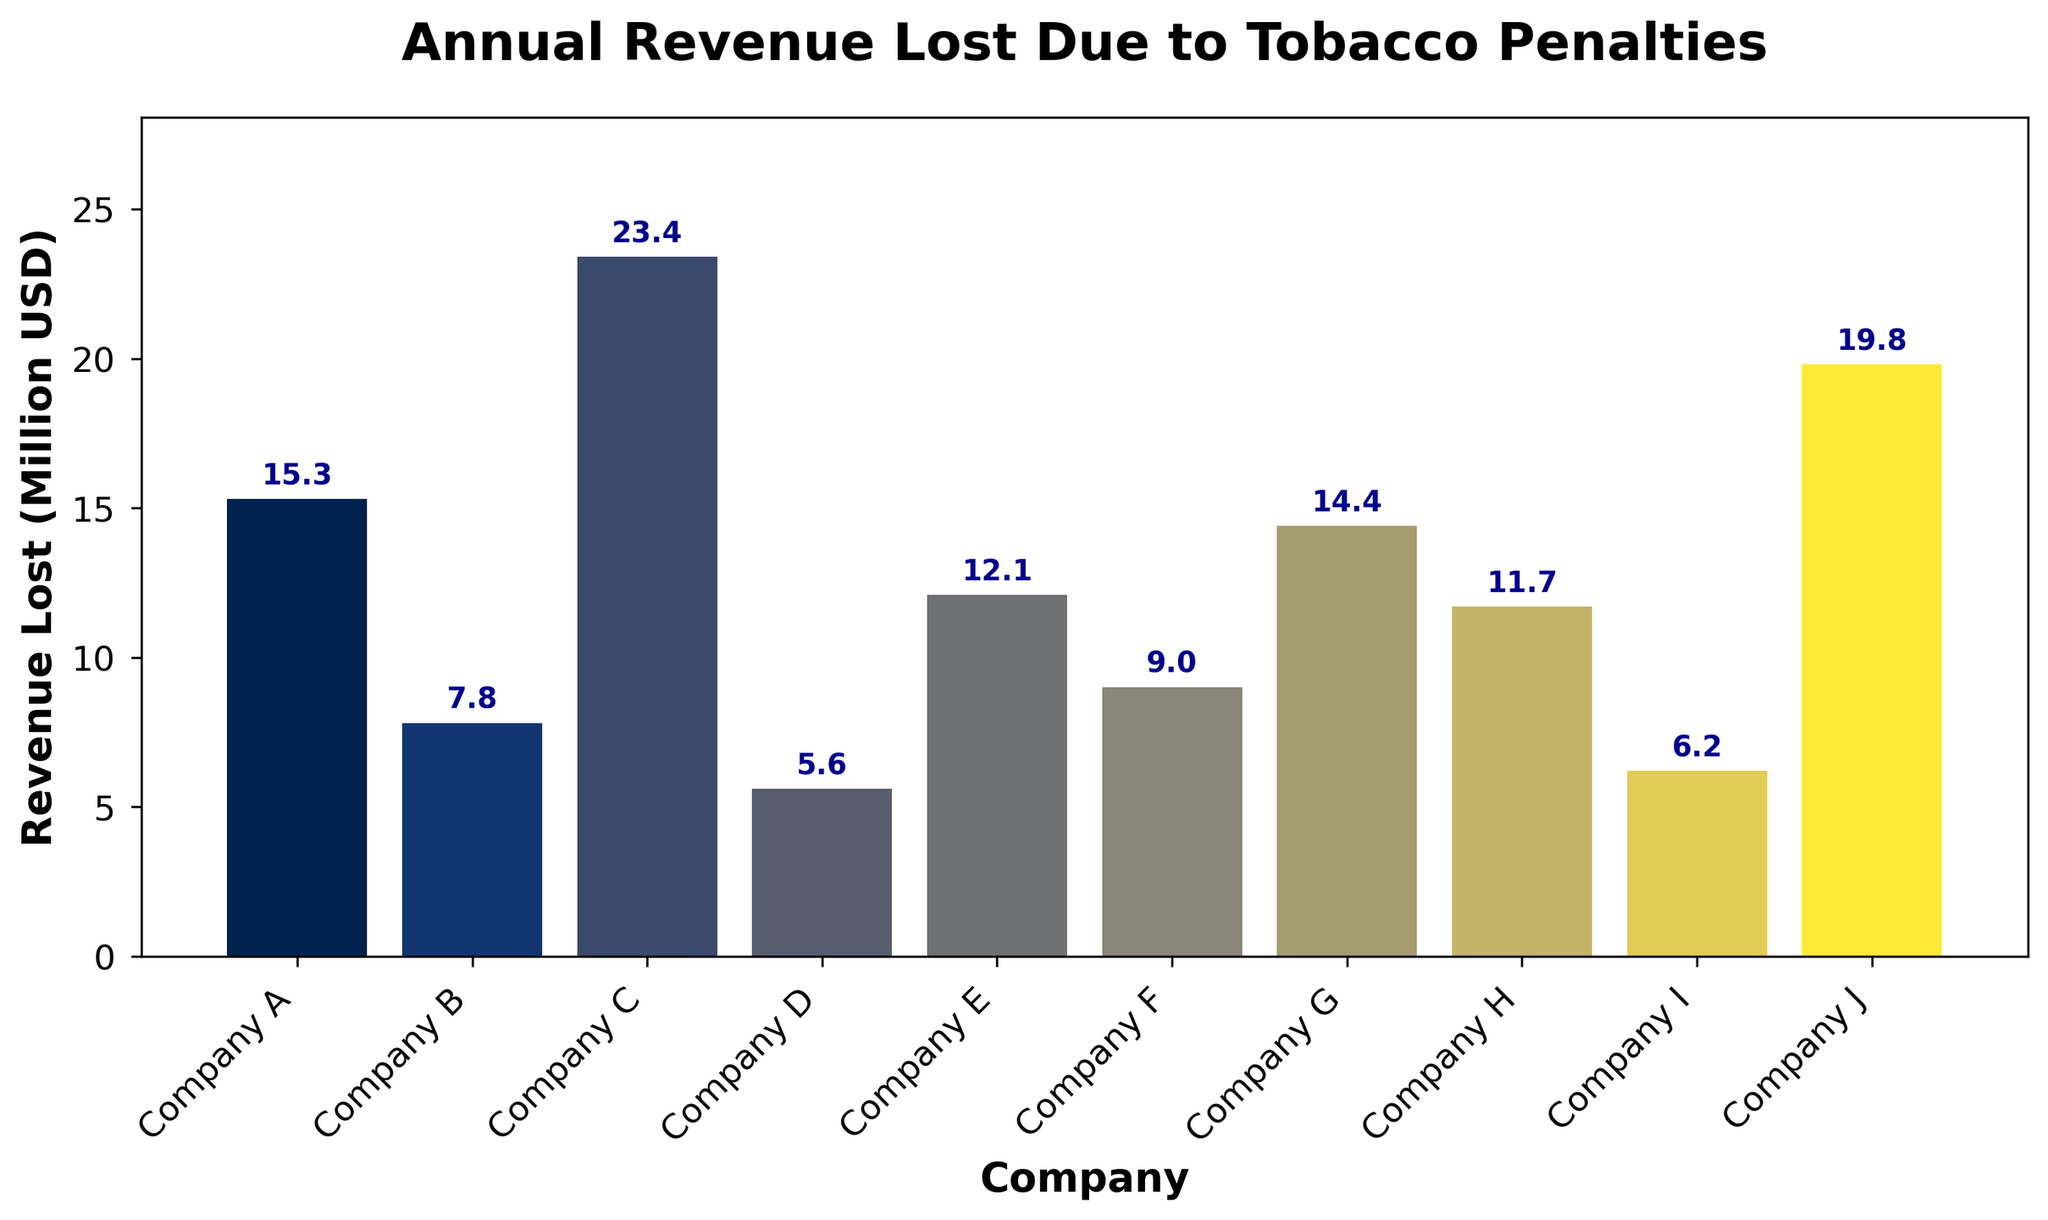Which company lost the most revenue due to tobacco penalties? The company with the highest bar in height lost the most revenue. In this case, Company C has the tallest bar.
Answer: Company C Which company lost the least revenue due to tobacco penalties? The company with the shortest bar lost the least revenue. In this case, Company D has the shortest bar.
Answer: Company D How much more revenue did Company C lose compared to Company D? Subtract the revenue lost by Company D (5.6 million USD) from the revenue lost by Company C (23.4 million USD): 23.4 - 5.6 = 17.8 million USD.
Answer: 17.8 million USD What is the total revenue lost by all companies combined? Sum the individual revenue losses: 15.3 + 7.8 + 23.4 + 5.6 + 12.1 + 9.0 + 14.4 + 11.7 + 6.2 + 19.8 = 125.3 million USD.
Answer: 125.3 million USD What is the average revenue lost due to tobacco penalties across all companies? Divide the total revenue lost by the number of companies: 125.3 million USD / 10 companies = 12.53 million USD.
Answer: 12.53 million USD Which two companies have the closest amounts of revenue lost, and what is the difference between them? Companies F and H have lost 9.0 and 11.7 million USD, respectively. The difference is
Answer: Company H and Company F How many companies lost more than 10 million USD in revenue due to tobacco penalties? Count the number of bars taller than the line representing 10 million USD: Companies A, B, C, E, G, H, and J.
Answer: 7 companies Which company has a bar that is approximately halfway between the maximum and minimum bar heights? Calculate the range of revenue lost: 23.4 (max) - 5.6 (min) = 17.8 million USD. Halfway would be 5.6 + 8.9 = 14.5 million USD. Closest bars are Company A (15.3) and Company G (14.4).
Answer: Company G 